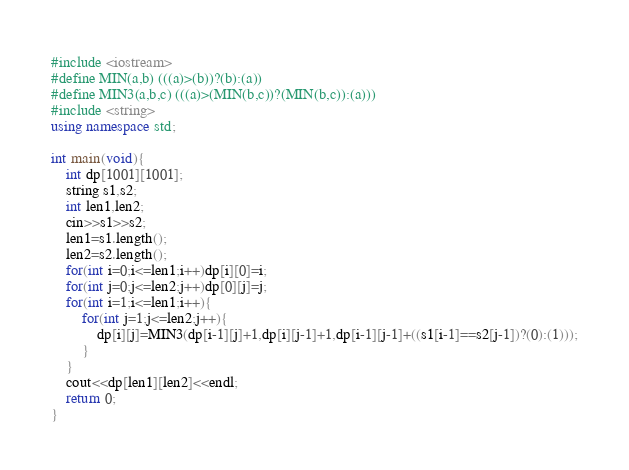<code> <loc_0><loc_0><loc_500><loc_500><_C++_>#include <iostream>
#define MIN(a,b) (((a)>(b))?(b):(a))
#define MIN3(a,b,c) (((a)>(MIN(b,c))?(MIN(b,c)):(a)))
#include <string>
using namespace std;

int main(void){
	int dp[1001][1001];
	string s1,s2;
	int len1,len2;
	cin>>s1>>s2;
	len1=s1.length();
	len2=s2.length();
	for(int i=0;i<=len1;i++)dp[i][0]=i;
	for(int j=0;j<=len2;j++)dp[0][j]=j;
	for(int i=1;i<=len1;i++){
		for(int j=1;j<=len2;j++){
			dp[i][j]=MIN3(dp[i-1][j]+1,dp[i][j-1]+1,dp[i-1][j-1]+((s1[i-1]==s2[j-1])?(0):(1)));
		}
	}
	cout<<dp[len1][len2]<<endl;
	return 0;
}</code> 